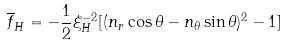Convert formula to latex. <formula><loc_0><loc_0><loc_500><loc_500>\overline { f } _ { H } = - \frac { 1 } { 2 } \xi _ { H } ^ { - 2 } [ ( n _ { r } \cos \theta - n _ { \theta } \sin \theta ) ^ { 2 } - 1 ]</formula> 